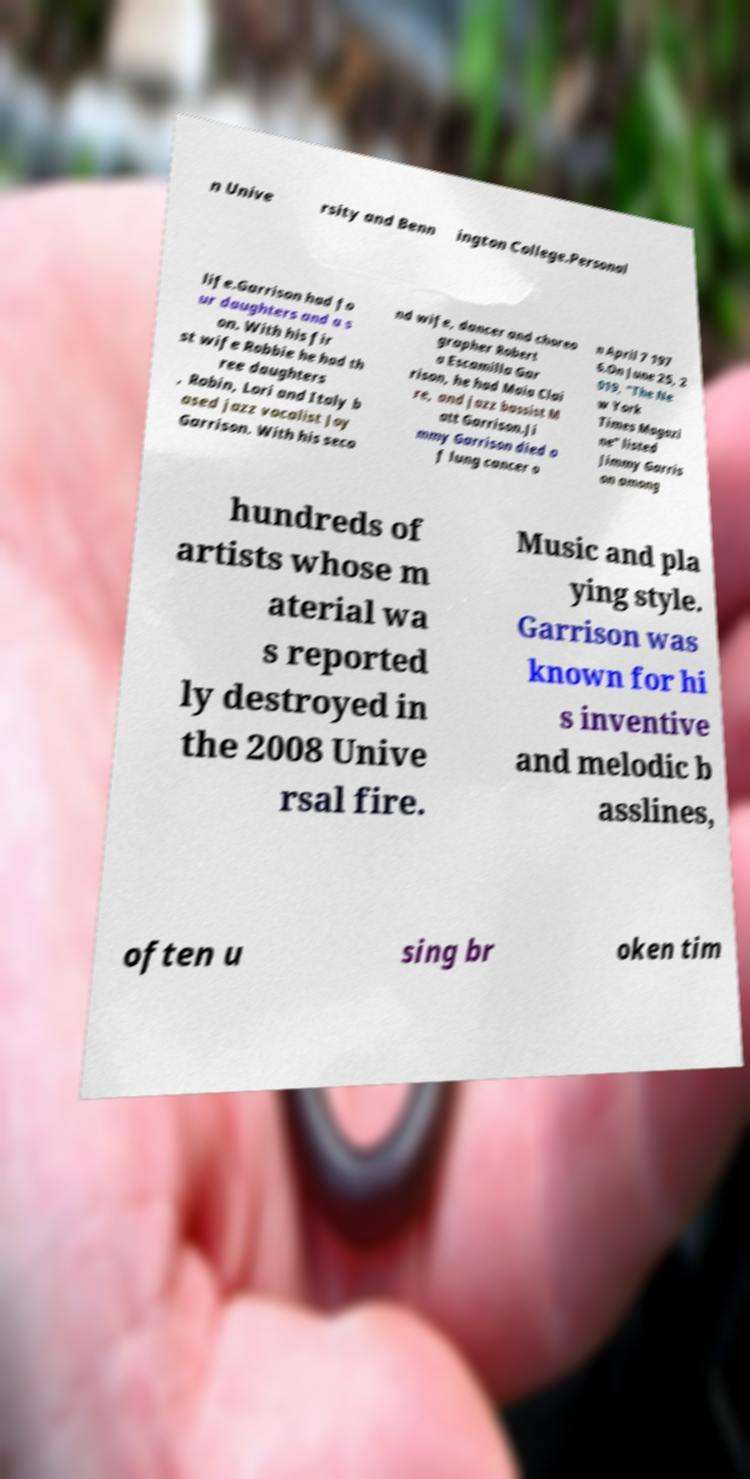Could you assist in decoding the text presented in this image and type it out clearly? n Unive rsity and Benn ington College.Personal life.Garrison had fo ur daughters and a s on. With his fir st wife Robbie he had th ree daughters , Robin, Lori and Italy b ased jazz vocalist Joy Garrison. With his seco nd wife, dancer and choreo grapher Robert a Escamilla Gar rison, he had Maia Clai re, and jazz bassist M att Garrison.Ji mmy Garrison died o f lung cancer o n April 7 197 6.On June 25, 2 019, "The Ne w York Times Magazi ne" listed Jimmy Garris on among hundreds of artists whose m aterial wa s reported ly destroyed in the 2008 Unive rsal fire. Music and pla ying style. Garrison was known for hi s inventive and melodic b asslines, often u sing br oken tim 